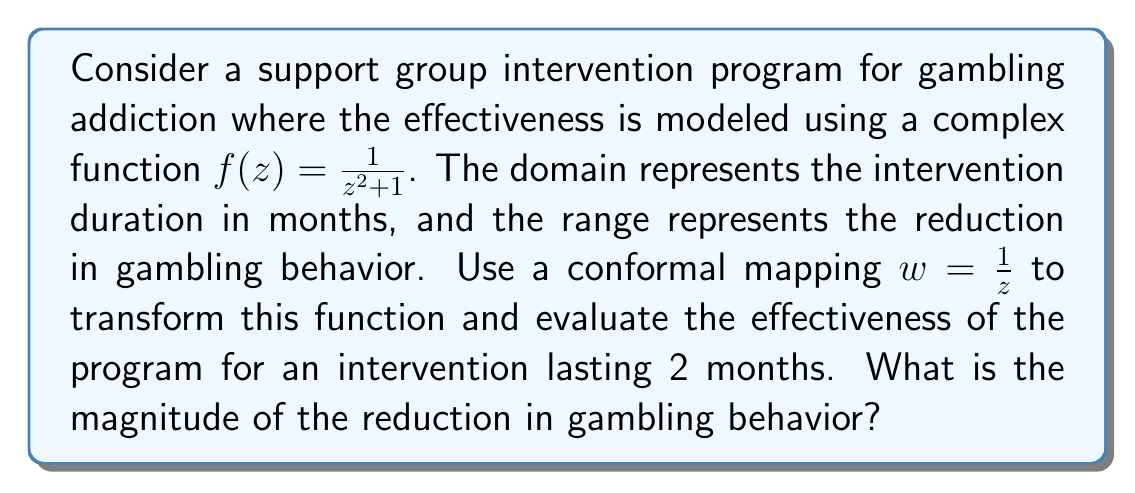Give your solution to this math problem. To solve this problem, we'll follow these steps:

1) First, we need to compose the given function $f(z) = \frac{1}{z^2 + 1}$ with the conformal mapping $w = \frac{1}{z}$. This gives us:

   $f(w) = f(\frac{1}{z}) = \frac{1}{(\frac{1}{z})^2 + 1} = \frac{1}{\frac{1}{z^2} + 1} = \frac{z^2}{1 + z^2}$

2) Now, we need to evaluate this function for an intervention lasting 2 months. In the original domain, this would be $z = 2$. However, in our transformed function, we need to use $z = \frac{1}{2}$:

   $f(\frac{1}{2}) = \frac{(\frac{1}{2})^2}{1 + (\frac{1}{2})^2} = \frac{\frac{1}{4}}{1 + \frac{1}{4}} = \frac{\frac{1}{4}}{\frac{5}{4}} = \frac{1}{5}$

3) The result $\frac{1}{5}$ is a complex number. To find its magnitude (which represents the reduction in gambling behavior), we need to calculate its absolute value:

   $|\frac{1}{5}| = \frac{1}{5} = 0.2$

Therefore, the magnitude of the reduction in gambling behavior after a 2-month intervention is 0.2 or 20%.
Answer: The magnitude of the reduction in gambling behavior is 0.2 or 20%. 